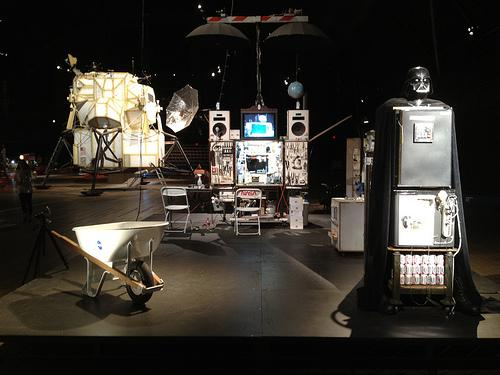Question: what color is the wheelbarrow?
Choices:
A. Brown.
B. Gray.
C. White.
D. Red.
Answer with the letter. Answer: C Question: who is the mask of?
Choices:
A. Lone Ranger.
B. Batman.
C. Darth Vader.
D. Phantom of the opera.
Answer with the letter. Answer: C Question: what time of day is it?
Choices:
A. Evening.
B. Twilight.
C. After dinner.
D. Night.
Answer with the letter. Answer: D Question: what color is the cape?
Choices:
A. Red.
B. Black.
C. Blue.
D. Green.
Answer with the letter. Answer: B Question: how many chairs are there?
Choices:
A. Four.
B. Two.
C. Five.
D. Six.
Answer with the letter. Answer: B Question: why is the wheelbarrow lit?
Choices:
A. In the sun.
B. In the moonshine.
C. It's by the fire.
D. There is a light on it.
Answer with the letter. Answer: D 